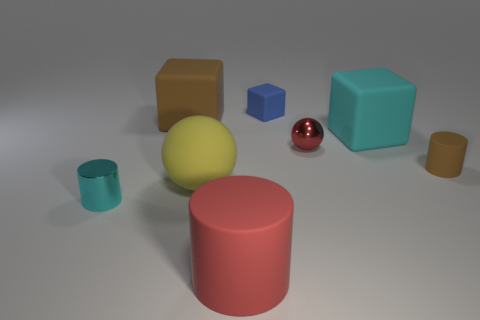Add 1 large brown blocks. How many objects exist? 9 Subtract all cylinders. How many objects are left? 5 Subtract all yellow rubber objects. Subtract all rubber cylinders. How many objects are left? 5 Add 3 rubber balls. How many rubber balls are left? 4 Add 4 rubber cylinders. How many rubber cylinders exist? 6 Subtract 1 brown cylinders. How many objects are left? 7 